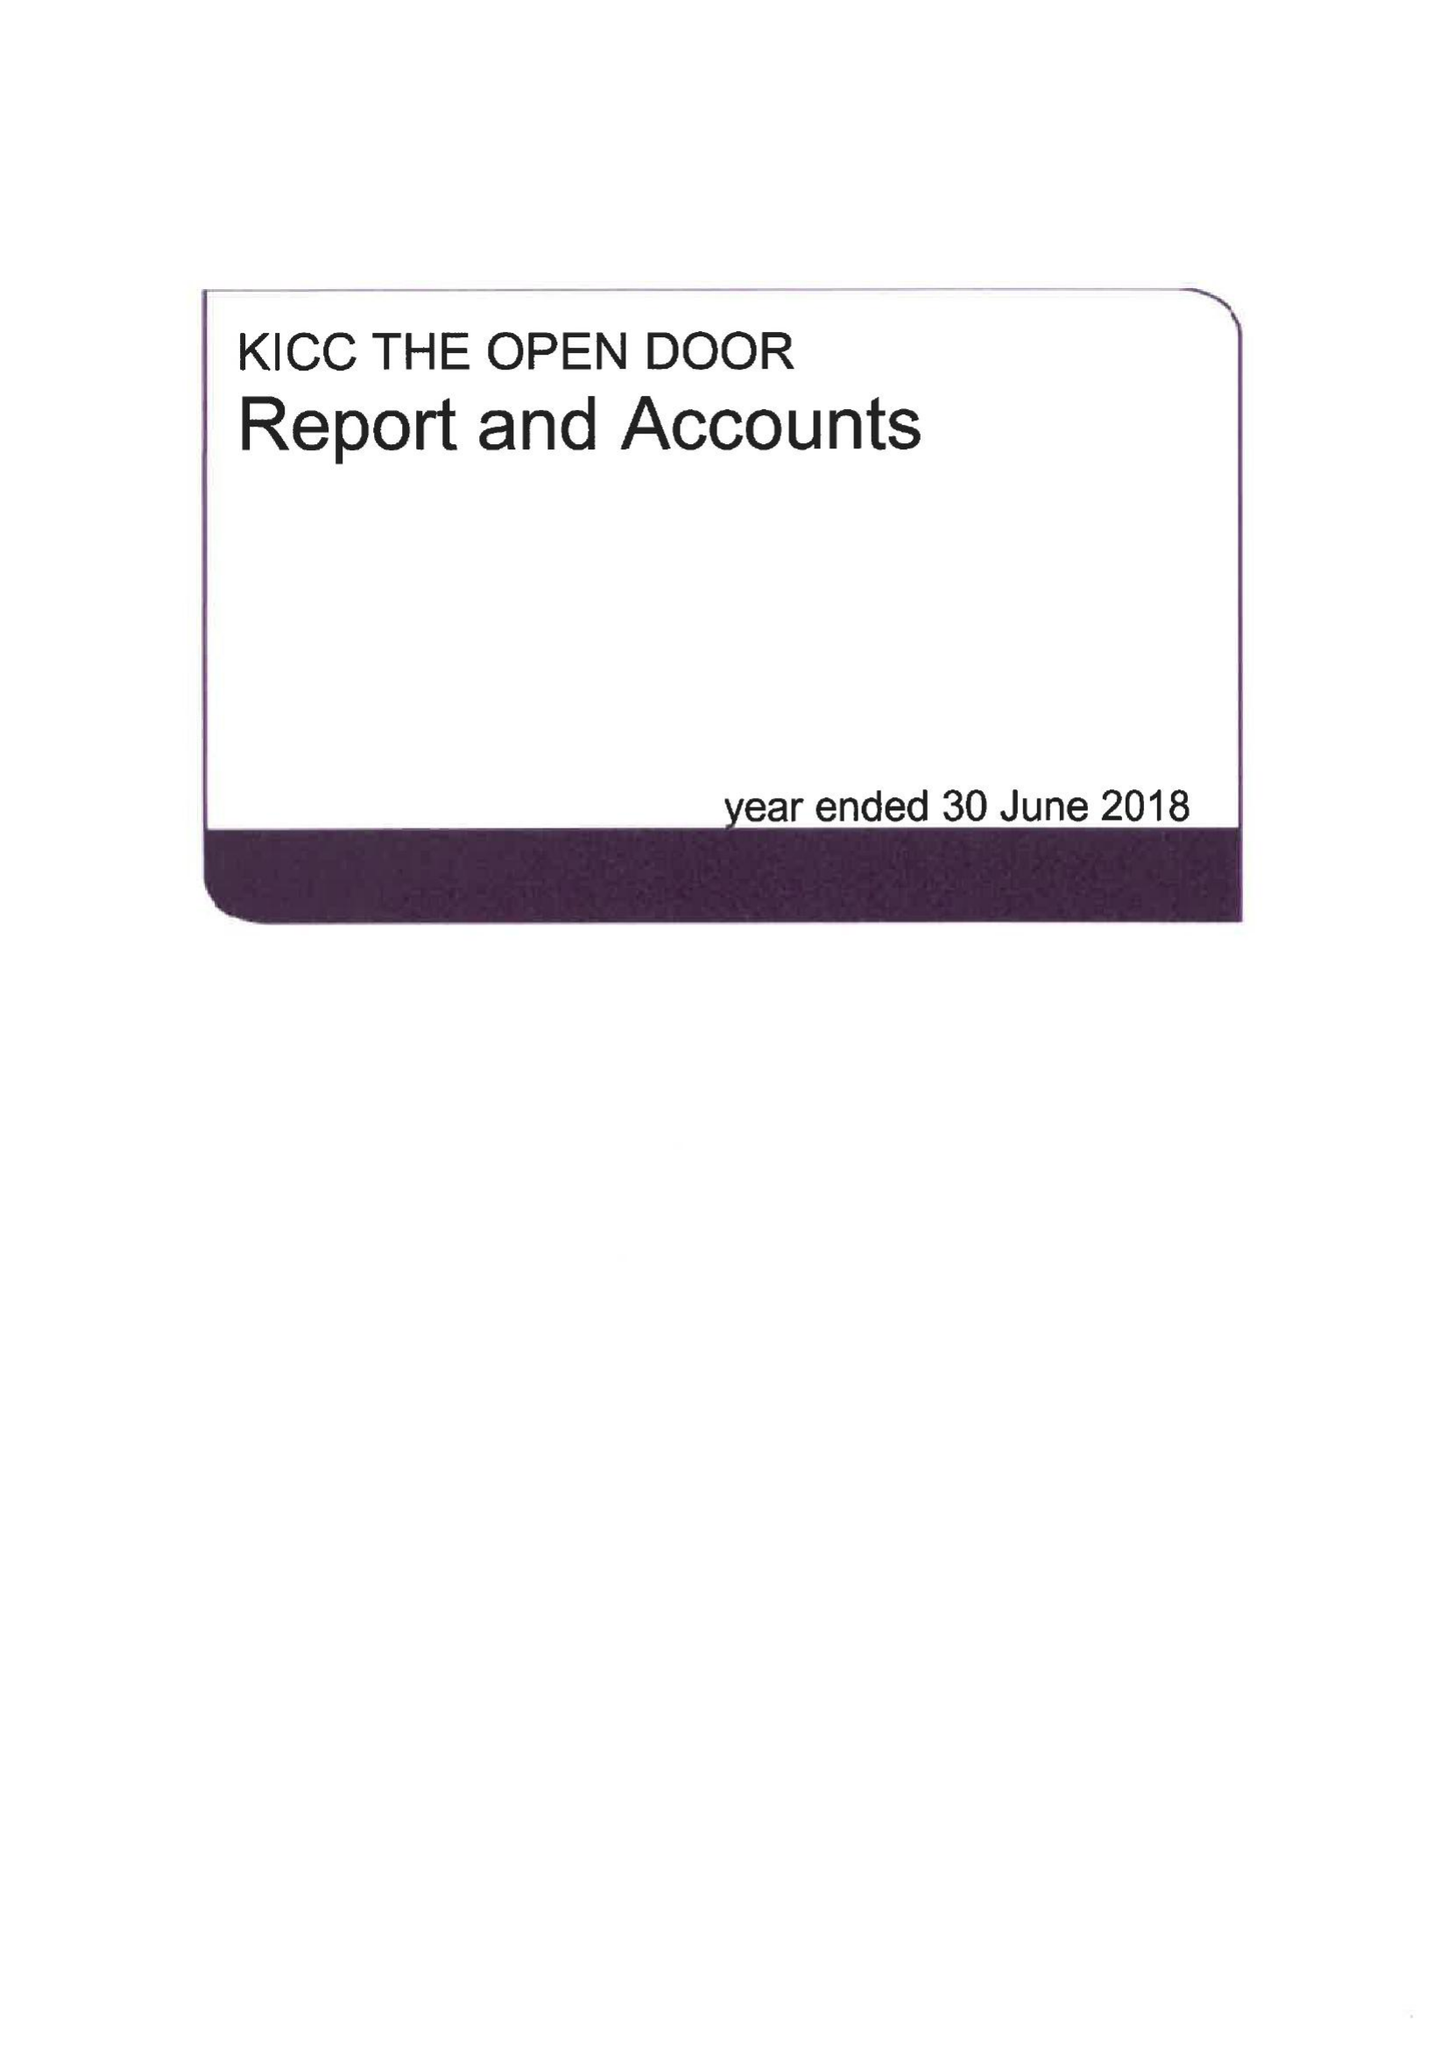What is the value for the charity_name?
Answer the question using a single word or phrase. Kicc The Open Door 